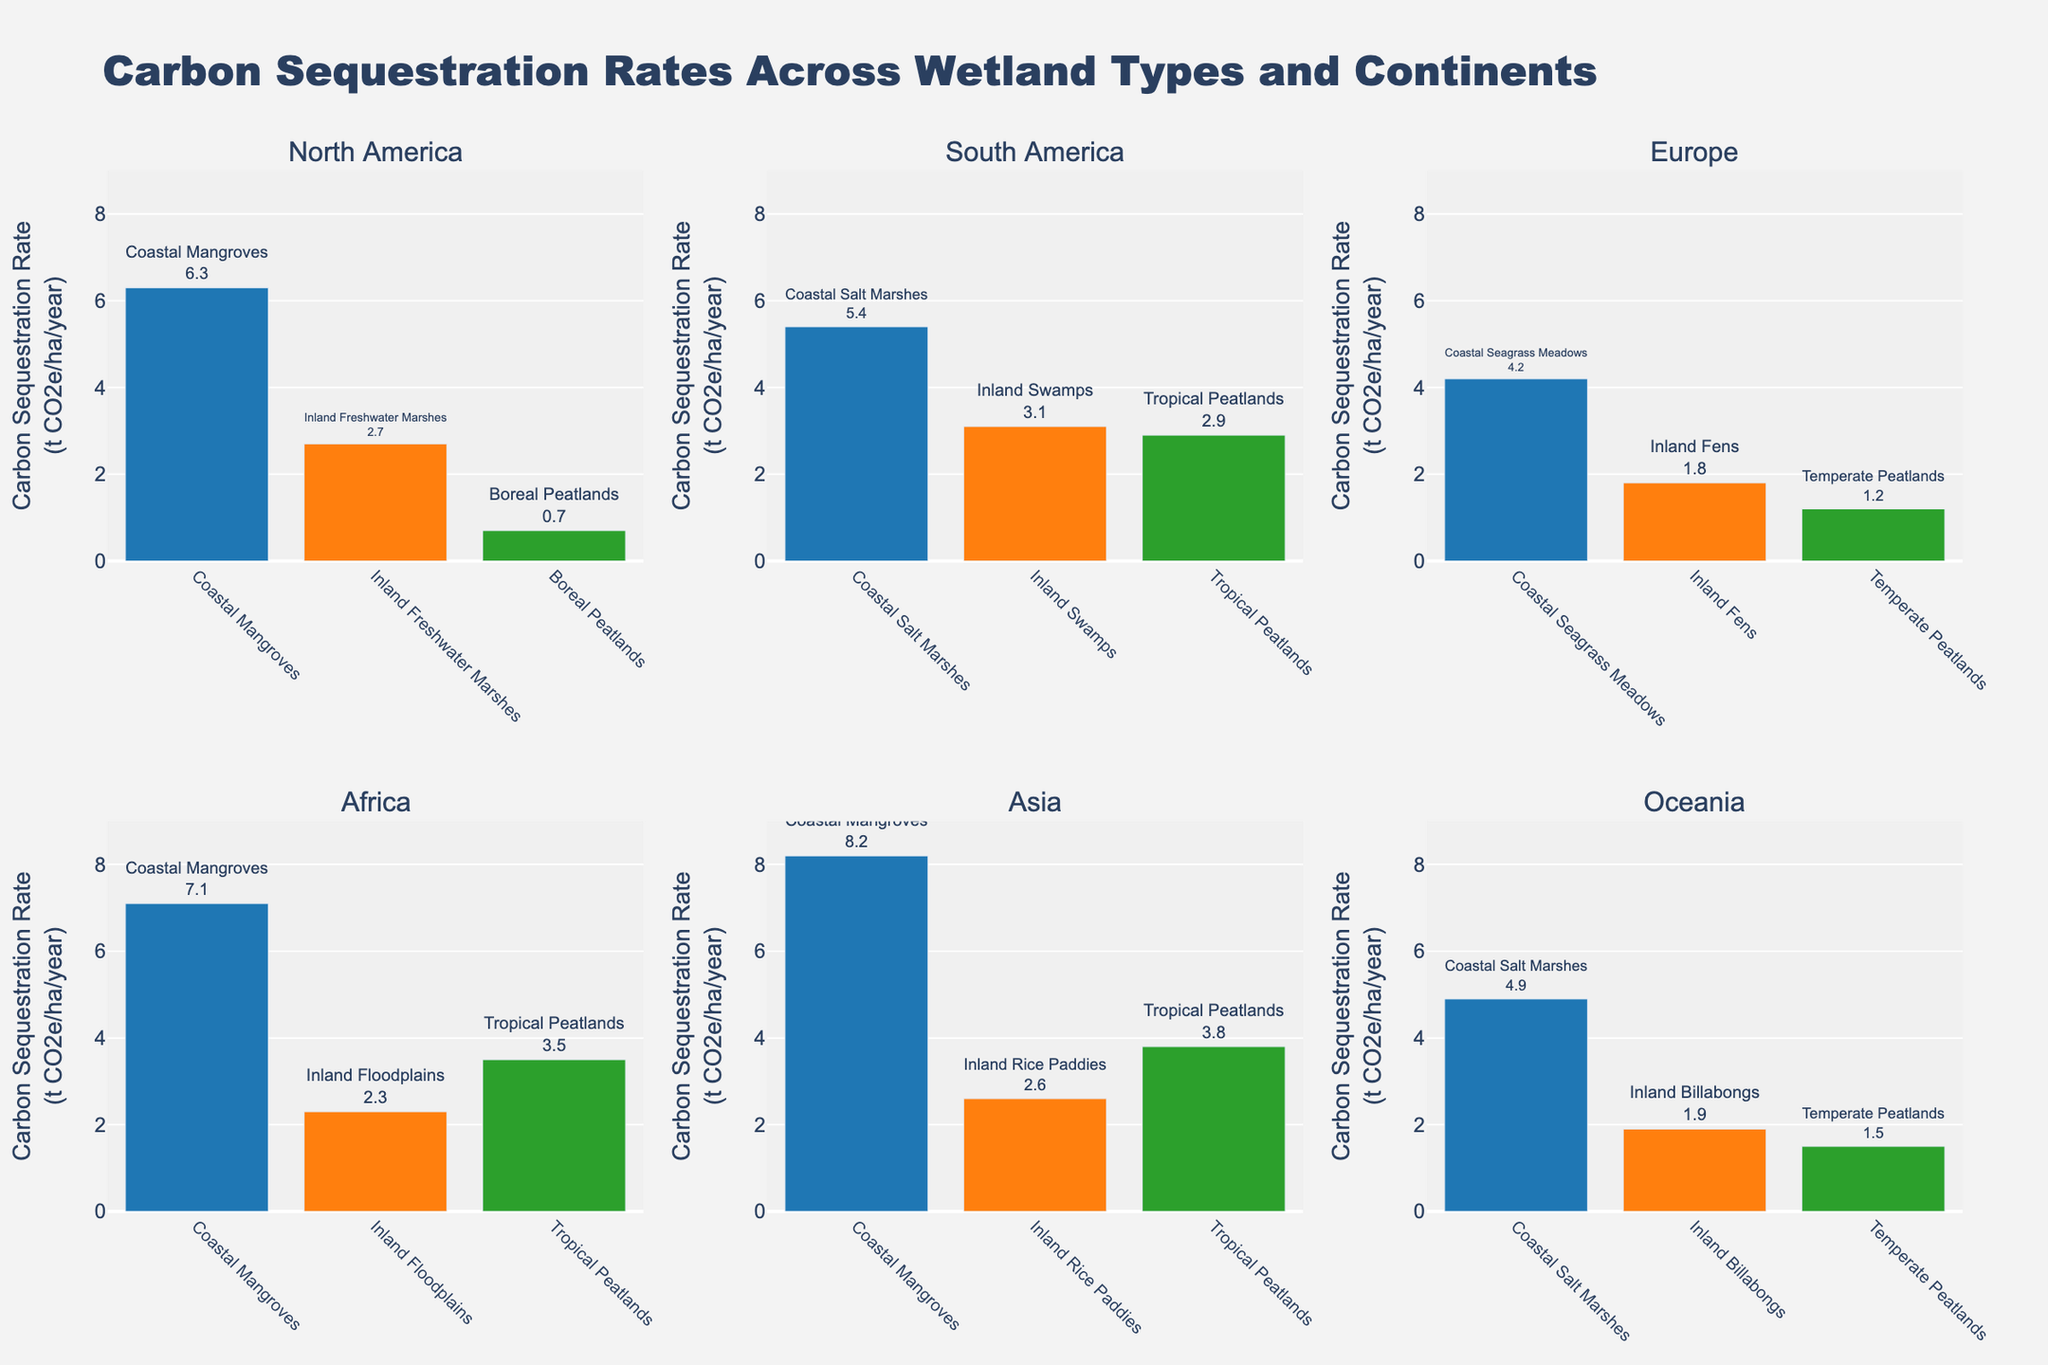What is the title of the figure? The title of the figure is displayed at the top center of the plot. It reads "Carbon Sequestration Rates Across Wetland Types and Continents".
Answer: Carbon Sequestration Rates Across Wetland Types and Continents Which wetland type on the North America subplot has the highest carbon sequestration rate? The North America subplot contains three wetland types: Coastal Mangroves (6.3 t CO2e/ha/year), Inland Freshwater Marshes (2.7 t CO2e/ha/year), and Boreal Peatlands (0.7 t CO2e/ha/year). The Coastal Mangroves have the highest rate.
Answer: Coastal Mangroves What is the range of carbon sequestration rates on the y-axis? The y-axis is labeled "Carbon Sequestration Rate (t CO2e/ha/year)" and has tick marks ranging from 0 to 9 with intervals of 2. The highest value shown on the y-axis is 9.
Answer: 0 to 9 Compare the carbon sequestration rates of Coastal Salt Marshes in South America and Oceania. Which has a higher rate and by how much? The rates are 5.4 t CO2e/ha/year for South America and 4.9 t CO2e/ha/year for Oceania. South America has a higher rate. The difference is 5.4 - 4.9 = 0.5.
Answer: South America by 0.5 t CO2e/ha/year What is the total carbon sequestration rate for all wetland types in Europe? The wetland types in Europe are Coastal Seagrass Meadows (4.2), Inland Fens (1.8), and Temperate Peatlands (1.2). The total rate is 4.2 + 1.8 + 1.2 = 7.2.
Answer: 7.2 On which continent do Tropical Peatlands have the highest carbon sequestration rate, and what is that rate? Tropical Peatlands are present in South America (2.9), Africa (3.5), and Asia (3.8). The highest rate is in Asia with a rate of 3.8.
Answer: Asia, 3.8 t CO2e/ha/year Which continent has the wetland type with the highest single carbon sequestration rate, and what is the wetland type? Asia has the highest rate with Coastal Mangroves sequestering 8.2 t CO2e/ha/year.
Answer: Asia, Coastal Mangroves Calculate the average carbon sequestration rate for all Coastal wetland types depicted in the figure. Coastal Mangroves: North America (6.3), Africa (7.1), Asia (8.2); Coastal Salt Marshes: South America (5.4), Oceania (4.9); Coastal Seagrass Meadows: Europe (4.2). The average is (6.3+7.1+8.2+5.4+4.9+4.2)/6=36.1/6=6.02.
Answer: 6.02 t CO2e/ha/year What is the difference between the highest (Asia) and lowest (Europe) carbon sequestration rates among Peatlands wetland types? The highest rate among Peatlands is in Asia (3.8), and the lowest is in Europe (1.2). The difference is 3.8 - 1.2 = 2.6.
Answer: 2.6 